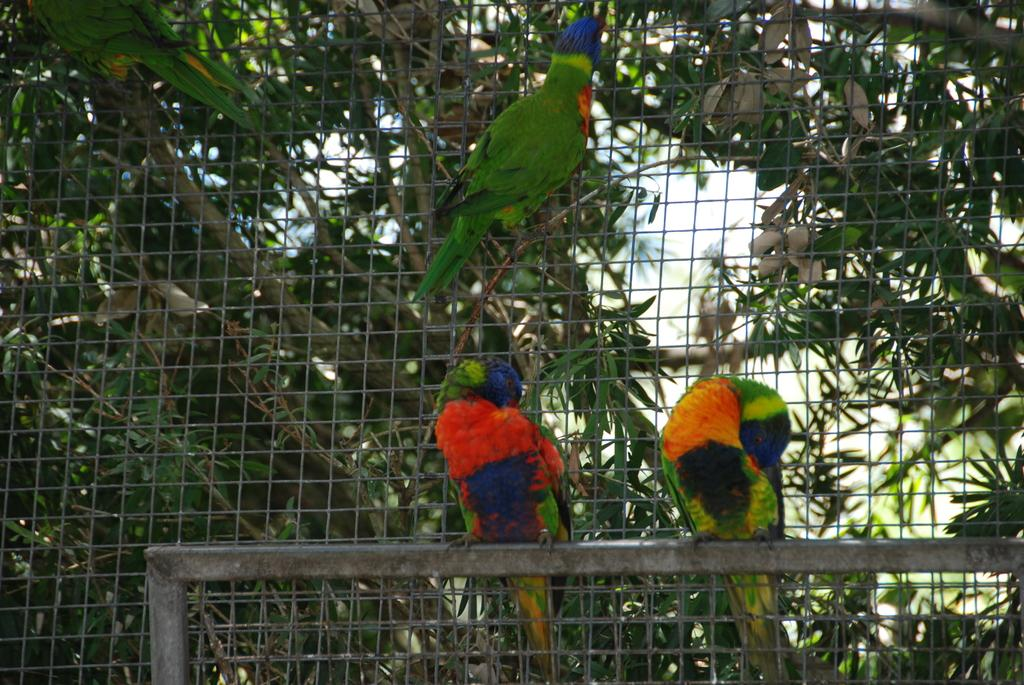What type of animals are in the image? There are parrots in the image. What is the structure that can be seen in the image? There is a mesh in the image. What can be seen in the background of the image? There is a tree and the sky visible in the background of the image. How many mittens are hanging from the tree in the image? There are no mittens present in the image; it features parrots and a mesh. 